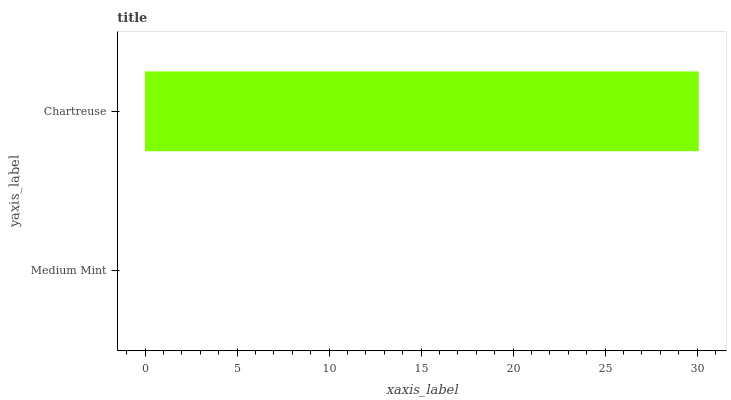Is Medium Mint the minimum?
Answer yes or no. Yes. Is Chartreuse the maximum?
Answer yes or no. Yes. Is Chartreuse the minimum?
Answer yes or no. No. Is Chartreuse greater than Medium Mint?
Answer yes or no. Yes. Is Medium Mint less than Chartreuse?
Answer yes or no. Yes. Is Medium Mint greater than Chartreuse?
Answer yes or no. No. Is Chartreuse less than Medium Mint?
Answer yes or no. No. Is Chartreuse the high median?
Answer yes or no. Yes. Is Medium Mint the low median?
Answer yes or no. Yes. Is Medium Mint the high median?
Answer yes or no. No. Is Chartreuse the low median?
Answer yes or no. No. 